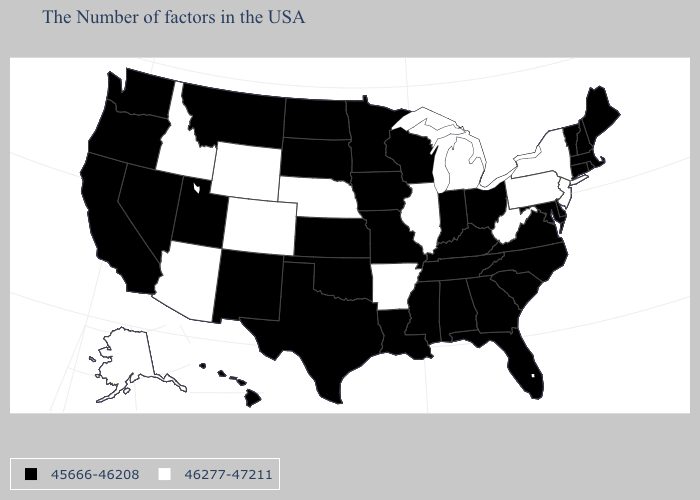Which states hav the highest value in the West?
Concise answer only. Wyoming, Colorado, Arizona, Idaho, Alaska. Does Illinois have the same value as Arkansas?
Write a very short answer. Yes. What is the highest value in the West ?
Quick response, please. 46277-47211. What is the highest value in the USA?
Quick response, please. 46277-47211. What is the value of Minnesota?
Quick response, please. 45666-46208. What is the highest value in states that border Connecticut?
Write a very short answer. 46277-47211. What is the highest value in the USA?
Answer briefly. 46277-47211. What is the value of Kentucky?
Give a very brief answer. 45666-46208. What is the value of Utah?
Short answer required. 45666-46208. Name the states that have a value in the range 45666-46208?
Be succinct. Maine, Massachusetts, Rhode Island, New Hampshire, Vermont, Connecticut, Delaware, Maryland, Virginia, North Carolina, South Carolina, Ohio, Florida, Georgia, Kentucky, Indiana, Alabama, Tennessee, Wisconsin, Mississippi, Louisiana, Missouri, Minnesota, Iowa, Kansas, Oklahoma, Texas, South Dakota, North Dakota, New Mexico, Utah, Montana, Nevada, California, Washington, Oregon, Hawaii. What is the value of Arizona?
Concise answer only. 46277-47211. Which states have the lowest value in the South?
Give a very brief answer. Delaware, Maryland, Virginia, North Carolina, South Carolina, Florida, Georgia, Kentucky, Alabama, Tennessee, Mississippi, Louisiana, Oklahoma, Texas. What is the value of Michigan?
Give a very brief answer. 46277-47211. Is the legend a continuous bar?
Answer briefly. No. 